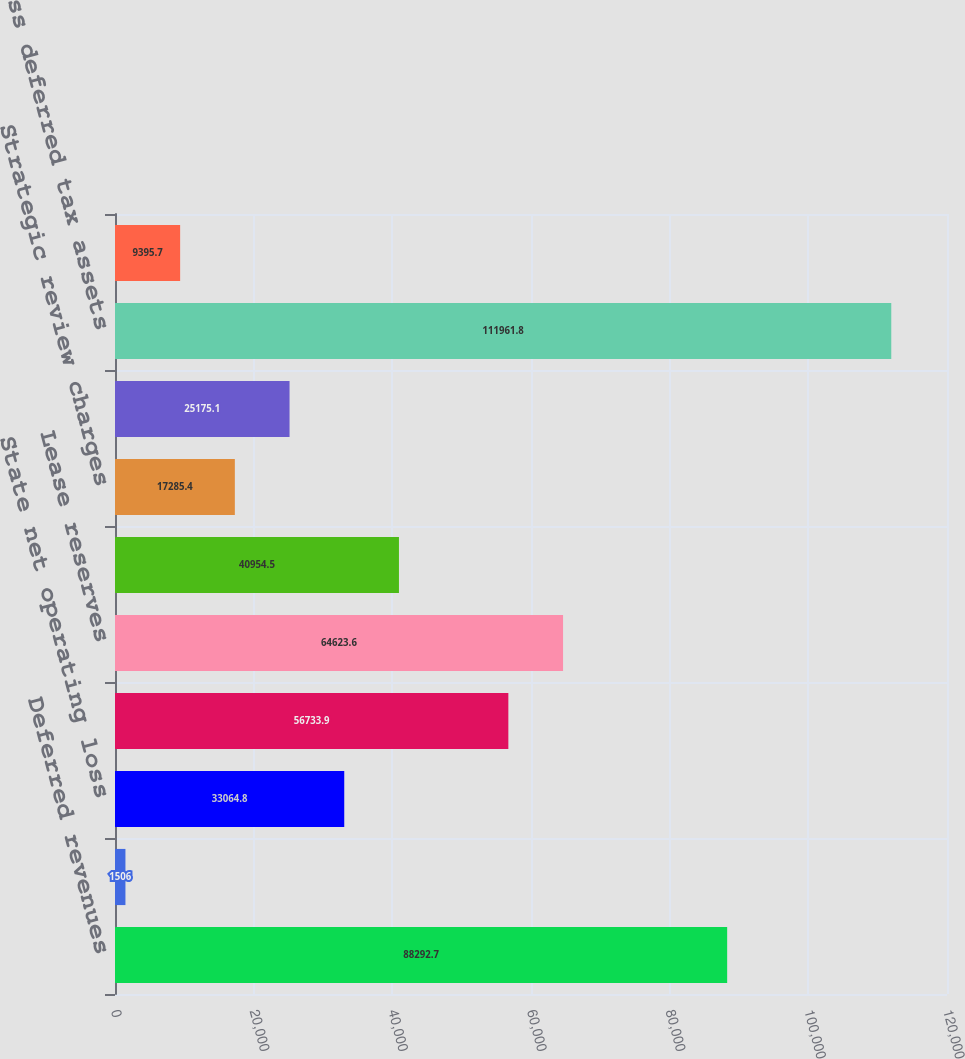Convert chart. <chart><loc_0><loc_0><loc_500><loc_500><bar_chart><fcel>Deferred revenues<fcel>Foreign net operating loss<fcel>State net operating loss<fcel>Compensation and benefits<fcel>Lease reserves<fcel>Capital loss carryforward<fcel>Strategic review charges<fcel>Other<fcel>Gross deferred tax assets<fcel>Depreciation<nl><fcel>88292.7<fcel>1506<fcel>33064.8<fcel>56733.9<fcel>64623.6<fcel>40954.5<fcel>17285.4<fcel>25175.1<fcel>111962<fcel>9395.7<nl></chart> 